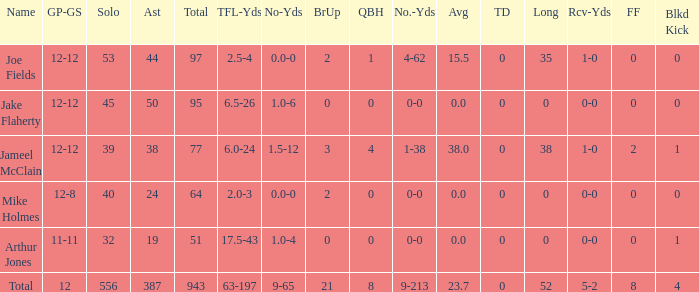7 average? 387.0. 